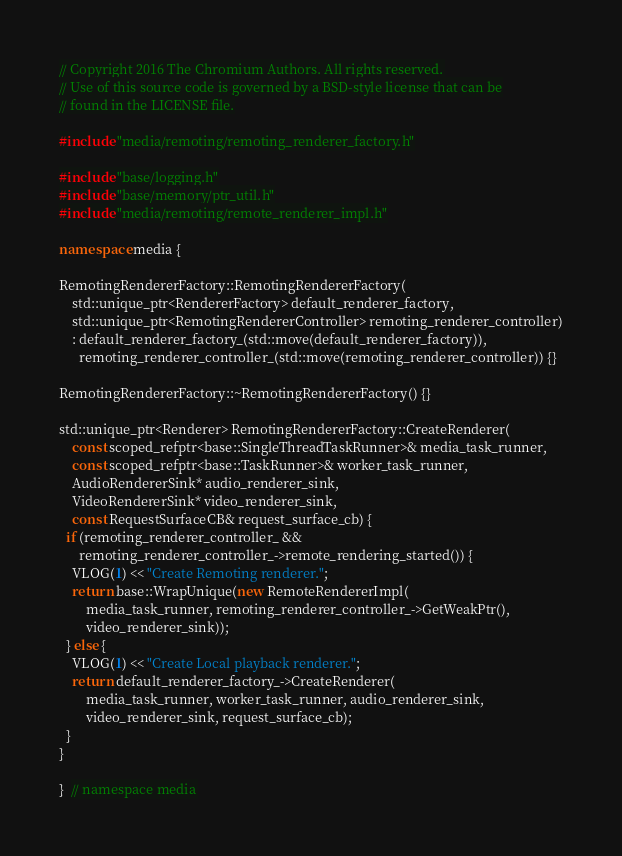<code> <loc_0><loc_0><loc_500><loc_500><_C++_>// Copyright 2016 The Chromium Authors. All rights reserved.
// Use of this source code is governed by a BSD-style license that can be
// found in the LICENSE file.

#include "media/remoting/remoting_renderer_factory.h"

#include "base/logging.h"
#include "base/memory/ptr_util.h"
#include "media/remoting/remote_renderer_impl.h"

namespace media {

RemotingRendererFactory::RemotingRendererFactory(
    std::unique_ptr<RendererFactory> default_renderer_factory,
    std::unique_ptr<RemotingRendererController> remoting_renderer_controller)
    : default_renderer_factory_(std::move(default_renderer_factory)),
      remoting_renderer_controller_(std::move(remoting_renderer_controller)) {}

RemotingRendererFactory::~RemotingRendererFactory() {}

std::unique_ptr<Renderer> RemotingRendererFactory::CreateRenderer(
    const scoped_refptr<base::SingleThreadTaskRunner>& media_task_runner,
    const scoped_refptr<base::TaskRunner>& worker_task_runner,
    AudioRendererSink* audio_renderer_sink,
    VideoRendererSink* video_renderer_sink,
    const RequestSurfaceCB& request_surface_cb) {
  if (remoting_renderer_controller_ &&
      remoting_renderer_controller_->remote_rendering_started()) {
    VLOG(1) << "Create Remoting renderer.";
    return base::WrapUnique(new RemoteRendererImpl(
        media_task_runner, remoting_renderer_controller_->GetWeakPtr(),
        video_renderer_sink));
  } else {
    VLOG(1) << "Create Local playback renderer.";
    return default_renderer_factory_->CreateRenderer(
        media_task_runner, worker_task_runner, audio_renderer_sink,
        video_renderer_sink, request_surface_cb);
  }
}

}  // namespace media
</code> 